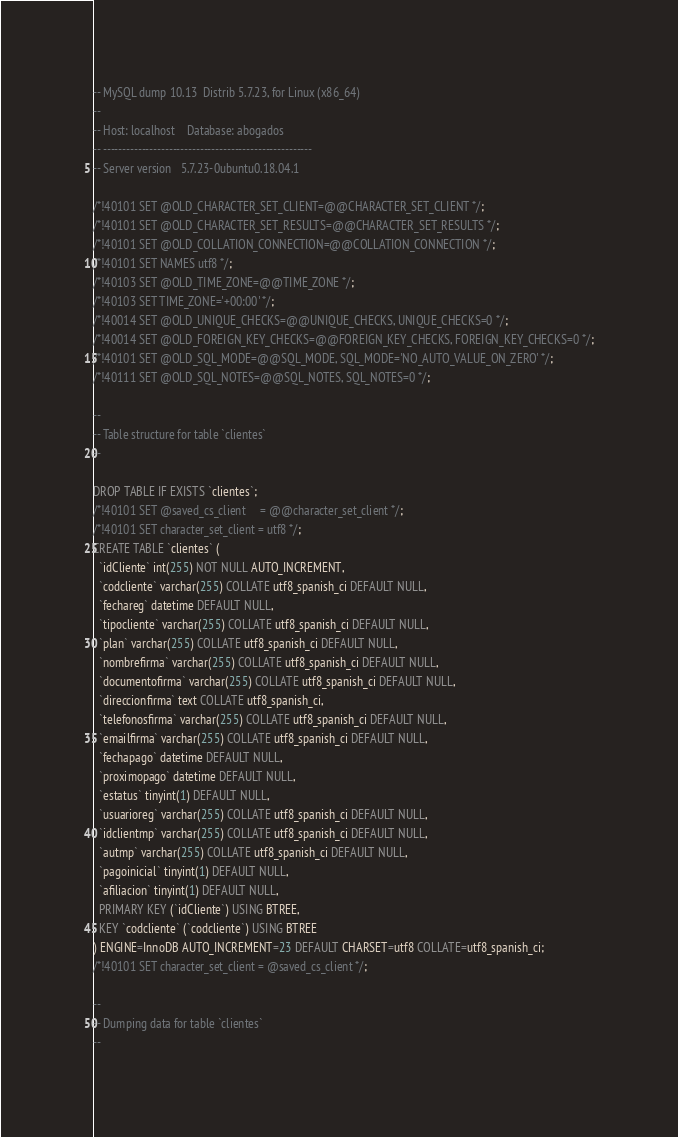Convert code to text. <code><loc_0><loc_0><loc_500><loc_500><_SQL_>-- MySQL dump 10.13  Distrib 5.7.23, for Linux (x86_64)
--
-- Host: localhost    Database: abogados
-- ------------------------------------------------------
-- Server version	5.7.23-0ubuntu0.18.04.1

/*!40101 SET @OLD_CHARACTER_SET_CLIENT=@@CHARACTER_SET_CLIENT */;
/*!40101 SET @OLD_CHARACTER_SET_RESULTS=@@CHARACTER_SET_RESULTS */;
/*!40101 SET @OLD_COLLATION_CONNECTION=@@COLLATION_CONNECTION */;
/*!40101 SET NAMES utf8 */;
/*!40103 SET @OLD_TIME_ZONE=@@TIME_ZONE */;
/*!40103 SET TIME_ZONE='+00:00' */;
/*!40014 SET @OLD_UNIQUE_CHECKS=@@UNIQUE_CHECKS, UNIQUE_CHECKS=0 */;
/*!40014 SET @OLD_FOREIGN_KEY_CHECKS=@@FOREIGN_KEY_CHECKS, FOREIGN_KEY_CHECKS=0 */;
/*!40101 SET @OLD_SQL_MODE=@@SQL_MODE, SQL_MODE='NO_AUTO_VALUE_ON_ZERO' */;
/*!40111 SET @OLD_SQL_NOTES=@@SQL_NOTES, SQL_NOTES=0 */;

--
-- Table structure for table `clientes`
--

DROP TABLE IF EXISTS `clientes`;
/*!40101 SET @saved_cs_client     = @@character_set_client */;
/*!40101 SET character_set_client = utf8 */;
CREATE TABLE `clientes` (
  `idCliente` int(255) NOT NULL AUTO_INCREMENT,
  `codcliente` varchar(255) COLLATE utf8_spanish_ci DEFAULT NULL,
  `fechareg` datetime DEFAULT NULL,
  `tipocliente` varchar(255) COLLATE utf8_spanish_ci DEFAULT NULL,
  `plan` varchar(255) COLLATE utf8_spanish_ci DEFAULT NULL,
  `nombrefirma` varchar(255) COLLATE utf8_spanish_ci DEFAULT NULL,
  `documentofirma` varchar(255) COLLATE utf8_spanish_ci DEFAULT NULL,
  `direccionfirma` text COLLATE utf8_spanish_ci,
  `telefonosfirma` varchar(255) COLLATE utf8_spanish_ci DEFAULT NULL,
  `emailfirma` varchar(255) COLLATE utf8_spanish_ci DEFAULT NULL,
  `fechapago` datetime DEFAULT NULL,
  `proximopago` datetime DEFAULT NULL,
  `estatus` tinyint(1) DEFAULT NULL,
  `usuarioreg` varchar(255) COLLATE utf8_spanish_ci DEFAULT NULL,
  `idclientmp` varchar(255) COLLATE utf8_spanish_ci DEFAULT NULL,
  `autmp` varchar(255) COLLATE utf8_spanish_ci DEFAULT NULL,
  `pagoinicial` tinyint(1) DEFAULT NULL,
  `afiliacion` tinyint(1) DEFAULT NULL,
  PRIMARY KEY (`idCliente`) USING BTREE,
  KEY `codcliente` (`codcliente`) USING BTREE
) ENGINE=InnoDB AUTO_INCREMENT=23 DEFAULT CHARSET=utf8 COLLATE=utf8_spanish_ci;
/*!40101 SET character_set_client = @saved_cs_client */;

--
-- Dumping data for table `clientes`
--
</code> 